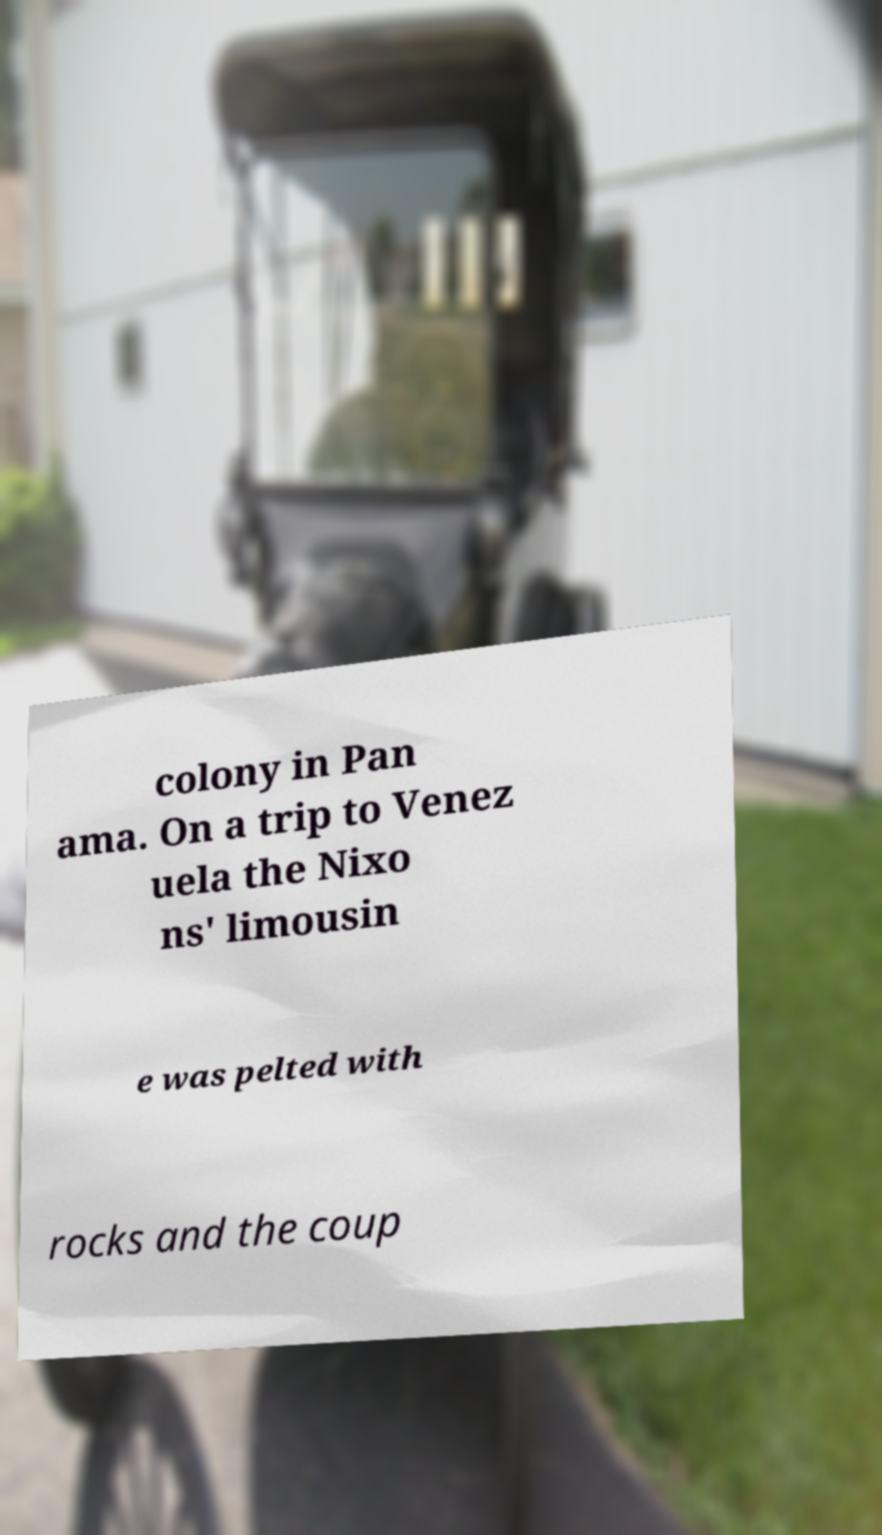What messages or text are displayed in this image? I need them in a readable, typed format. colony in Pan ama. On a trip to Venez uela the Nixo ns' limousin e was pelted with rocks and the coup 